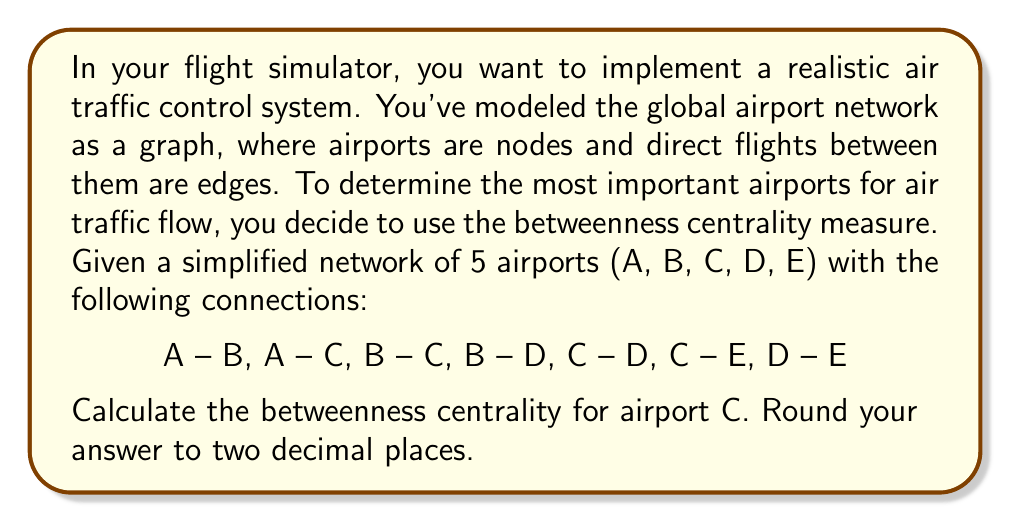Can you solve this math problem? To calculate the betweenness centrality for airport C, we need to follow these steps:

1) First, let's understand what betweenness centrality means. For a node v, it's the sum of the fraction of all-pairs shortest paths that pass through v.

2) The formula for betweenness centrality is:

   $$BC(v) = \sum_{s \neq v \neq t} \frac{\sigma_{st}(v)}{\sigma_{st}}$$

   Where $\sigma_{st}$ is the total number of shortest paths from node s to node t, and $\sigma_{st}(v)$ is the number of those paths passing through v.

3) In our network, we need to consider all pairs of airports excluding C, and count how many shortest paths between them pass through C.

4) Let's list all pairs and their shortest paths:
   A-B: direct (doesn't pass through C)
   A-D: A-C-D (passes through C)
   A-E: A-C-E (passes through C)
   B-D: direct (doesn't pass through C)
   B-E: B-C-E and B-D-E (1 of 2 paths passes through C)
   D-E: direct (doesn't pass through C)

5) Now, let's sum the fractions:
   A-D: 1
   A-E: 1
   B-E: 1/2

6) Therefore, the betweenness centrality for C is:

   $$BC(C) = 1 + 1 + \frac{1}{2} = 2.5$$

7) Rounding to two decimal places: 2.50
Answer: 2.50 